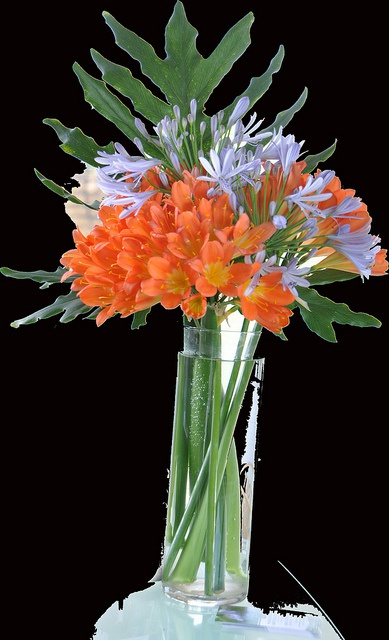Describe the objects in this image and their specific colors. I can see a vase in black, green, lightgray, lightblue, and darkgray tones in this image. 